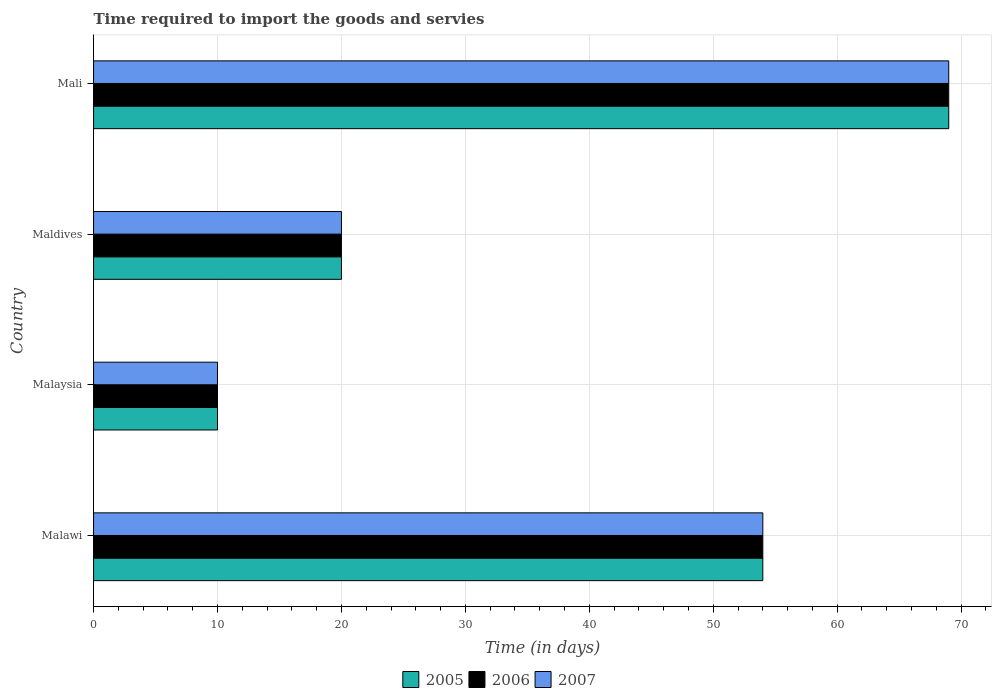How many different coloured bars are there?
Your response must be concise. 3. Are the number of bars per tick equal to the number of legend labels?
Your answer should be compact. Yes. How many bars are there on the 3rd tick from the top?
Make the answer very short. 3. How many bars are there on the 4th tick from the bottom?
Ensure brevity in your answer.  3. What is the label of the 2nd group of bars from the top?
Make the answer very short. Maldives. In how many cases, is the number of bars for a given country not equal to the number of legend labels?
Give a very brief answer. 0. What is the number of days required to import the goods and services in 2007 in Maldives?
Ensure brevity in your answer.  20. Across all countries, what is the maximum number of days required to import the goods and services in 2006?
Make the answer very short. 69. Across all countries, what is the minimum number of days required to import the goods and services in 2007?
Your answer should be very brief. 10. In which country was the number of days required to import the goods and services in 2005 maximum?
Give a very brief answer. Mali. In which country was the number of days required to import the goods and services in 2005 minimum?
Keep it short and to the point. Malaysia. What is the total number of days required to import the goods and services in 2007 in the graph?
Your answer should be compact. 153. What is the difference between the number of days required to import the goods and services in 2005 in Malaysia and the number of days required to import the goods and services in 2006 in Mali?
Your response must be concise. -59. What is the average number of days required to import the goods and services in 2005 per country?
Offer a terse response. 38.25. What is the difference between the number of days required to import the goods and services in 2005 and number of days required to import the goods and services in 2006 in Malaysia?
Make the answer very short. 0. In how many countries, is the number of days required to import the goods and services in 2005 greater than 70 days?
Provide a succinct answer. 0. What is the ratio of the number of days required to import the goods and services in 2007 in Malaysia to that in Mali?
Offer a terse response. 0.14. Is the number of days required to import the goods and services in 2007 in Maldives less than that in Mali?
Give a very brief answer. Yes. What is the difference between the highest and the second highest number of days required to import the goods and services in 2006?
Your answer should be compact. 15. What is the difference between the highest and the lowest number of days required to import the goods and services in 2006?
Provide a short and direct response. 59. Is the sum of the number of days required to import the goods and services in 2007 in Malaysia and Maldives greater than the maximum number of days required to import the goods and services in 2006 across all countries?
Provide a succinct answer. No. What does the 3rd bar from the bottom in Malawi represents?
Your answer should be compact. 2007. Is it the case that in every country, the sum of the number of days required to import the goods and services in 2007 and number of days required to import the goods and services in 2005 is greater than the number of days required to import the goods and services in 2006?
Offer a terse response. Yes. How many bars are there?
Make the answer very short. 12. Are the values on the major ticks of X-axis written in scientific E-notation?
Your answer should be compact. No. What is the title of the graph?
Your answer should be very brief. Time required to import the goods and servies. What is the label or title of the X-axis?
Ensure brevity in your answer.  Time (in days). What is the label or title of the Y-axis?
Ensure brevity in your answer.  Country. What is the Time (in days) of 2006 in Malawi?
Ensure brevity in your answer.  54. What is the Time (in days) of 2007 in Malawi?
Provide a succinct answer. 54. What is the Time (in days) of 2006 in Malaysia?
Your answer should be very brief. 10. What is the Time (in days) in 2007 in Malaysia?
Your answer should be very brief. 10. What is the Time (in days) in 2005 in Maldives?
Provide a short and direct response. 20. What is the Time (in days) in 2006 in Maldives?
Provide a succinct answer. 20. What is the Time (in days) of 2005 in Mali?
Offer a very short reply. 69. What is the Time (in days) in 2006 in Mali?
Your answer should be compact. 69. Across all countries, what is the maximum Time (in days) in 2005?
Offer a terse response. 69. What is the total Time (in days) in 2005 in the graph?
Ensure brevity in your answer.  153. What is the total Time (in days) of 2006 in the graph?
Your answer should be compact. 153. What is the total Time (in days) in 2007 in the graph?
Provide a short and direct response. 153. What is the difference between the Time (in days) in 2005 in Malawi and that in Malaysia?
Offer a terse response. 44. What is the difference between the Time (in days) in 2006 in Malawi and that in Malaysia?
Ensure brevity in your answer.  44. What is the difference between the Time (in days) in 2005 in Malawi and that in Maldives?
Provide a short and direct response. 34. What is the difference between the Time (in days) of 2006 in Malawi and that in Maldives?
Offer a very short reply. 34. What is the difference between the Time (in days) in 2005 in Malawi and that in Mali?
Give a very brief answer. -15. What is the difference between the Time (in days) of 2006 in Malawi and that in Mali?
Give a very brief answer. -15. What is the difference between the Time (in days) of 2007 in Malawi and that in Mali?
Ensure brevity in your answer.  -15. What is the difference between the Time (in days) of 2006 in Malaysia and that in Maldives?
Keep it short and to the point. -10. What is the difference between the Time (in days) in 2007 in Malaysia and that in Maldives?
Your answer should be very brief. -10. What is the difference between the Time (in days) in 2005 in Malaysia and that in Mali?
Your answer should be compact. -59. What is the difference between the Time (in days) of 2006 in Malaysia and that in Mali?
Keep it short and to the point. -59. What is the difference between the Time (in days) in 2007 in Malaysia and that in Mali?
Your response must be concise. -59. What is the difference between the Time (in days) of 2005 in Maldives and that in Mali?
Offer a very short reply. -49. What is the difference between the Time (in days) of 2006 in Maldives and that in Mali?
Offer a very short reply. -49. What is the difference between the Time (in days) in 2007 in Maldives and that in Mali?
Your answer should be very brief. -49. What is the difference between the Time (in days) of 2005 in Malawi and the Time (in days) of 2006 in Malaysia?
Offer a very short reply. 44. What is the difference between the Time (in days) in 2005 in Malawi and the Time (in days) in 2006 in Maldives?
Provide a succinct answer. 34. What is the difference between the Time (in days) in 2005 in Malawi and the Time (in days) in 2007 in Maldives?
Keep it short and to the point. 34. What is the difference between the Time (in days) in 2005 in Malawi and the Time (in days) in 2007 in Mali?
Provide a short and direct response. -15. What is the difference between the Time (in days) of 2006 in Malawi and the Time (in days) of 2007 in Mali?
Ensure brevity in your answer.  -15. What is the difference between the Time (in days) in 2005 in Malaysia and the Time (in days) in 2006 in Maldives?
Keep it short and to the point. -10. What is the difference between the Time (in days) in 2005 in Malaysia and the Time (in days) in 2006 in Mali?
Offer a very short reply. -59. What is the difference between the Time (in days) in 2005 in Malaysia and the Time (in days) in 2007 in Mali?
Your answer should be very brief. -59. What is the difference between the Time (in days) in 2006 in Malaysia and the Time (in days) in 2007 in Mali?
Offer a very short reply. -59. What is the difference between the Time (in days) in 2005 in Maldives and the Time (in days) in 2006 in Mali?
Provide a short and direct response. -49. What is the difference between the Time (in days) in 2005 in Maldives and the Time (in days) in 2007 in Mali?
Keep it short and to the point. -49. What is the difference between the Time (in days) of 2006 in Maldives and the Time (in days) of 2007 in Mali?
Provide a succinct answer. -49. What is the average Time (in days) in 2005 per country?
Give a very brief answer. 38.25. What is the average Time (in days) in 2006 per country?
Offer a terse response. 38.25. What is the average Time (in days) of 2007 per country?
Offer a terse response. 38.25. What is the difference between the Time (in days) in 2006 and Time (in days) in 2007 in Malawi?
Provide a succinct answer. 0. What is the difference between the Time (in days) of 2005 and Time (in days) of 2007 in Maldives?
Offer a very short reply. 0. What is the difference between the Time (in days) of 2006 and Time (in days) of 2007 in Maldives?
Provide a succinct answer. 0. What is the difference between the Time (in days) of 2005 and Time (in days) of 2006 in Mali?
Provide a short and direct response. 0. What is the ratio of the Time (in days) of 2006 in Malawi to that in Malaysia?
Make the answer very short. 5.4. What is the ratio of the Time (in days) of 2007 in Malawi to that in Malaysia?
Provide a succinct answer. 5.4. What is the ratio of the Time (in days) of 2005 in Malawi to that in Maldives?
Give a very brief answer. 2.7. What is the ratio of the Time (in days) of 2007 in Malawi to that in Maldives?
Give a very brief answer. 2.7. What is the ratio of the Time (in days) of 2005 in Malawi to that in Mali?
Your response must be concise. 0.78. What is the ratio of the Time (in days) of 2006 in Malawi to that in Mali?
Provide a succinct answer. 0.78. What is the ratio of the Time (in days) of 2007 in Malawi to that in Mali?
Provide a short and direct response. 0.78. What is the ratio of the Time (in days) in 2005 in Malaysia to that in Maldives?
Give a very brief answer. 0.5. What is the ratio of the Time (in days) of 2007 in Malaysia to that in Maldives?
Offer a very short reply. 0.5. What is the ratio of the Time (in days) in 2005 in Malaysia to that in Mali?
Your answer should be very brief. 0.14. What is the ratio of the Time (in days) in 2006 in Malaysia to that in Mali?
Provide a short and direct response. 0.14. What is the ratio of the Time (in days) of 2007 in Malaysia to that in Mali?
Provide a short and direct response. 0.14. What is the ratio of the Time (in days) of 2005 in Maldives to that in Mali?
Ensure brevity in your answer.  0.29. What is the ratio of the Time (in days) of 2006 in Maldives to that in Mali?
Make the answer very short. 0.29. What is the ratio of the Time (in days) in 2007 in Maldives to that in Mali?
Provide a short and direct response. 0.29. What is the difference between the highest and the second highest Time (in days) in 2005?
Keep it short and to the point. 15. What is the difference between the highest and the second highest Time (in days) of 2007?
Your answer should be compact. 15. What is the difference between the highest and the lowest Time (in days) of 2007?
Provide a short and direct response. 59. 